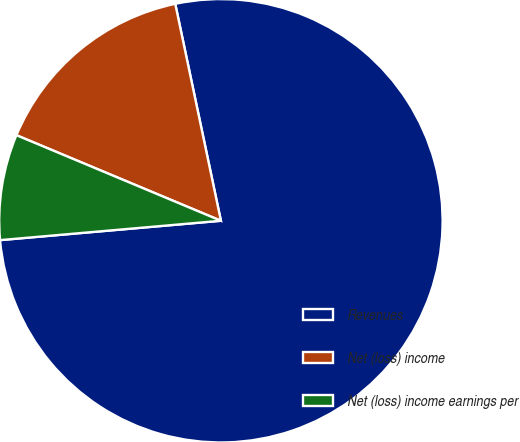Convert chart to OTSL. <chart><loc_0><loc_0><loc_500><loc_500><pie_chart><fcel>Revenues<fcel>Net (loss) income<fcel>Net (loss) income earnings per<nl><fcel>76.91%<fcel>15.39%<fcel>7.7%<nl></chart> 